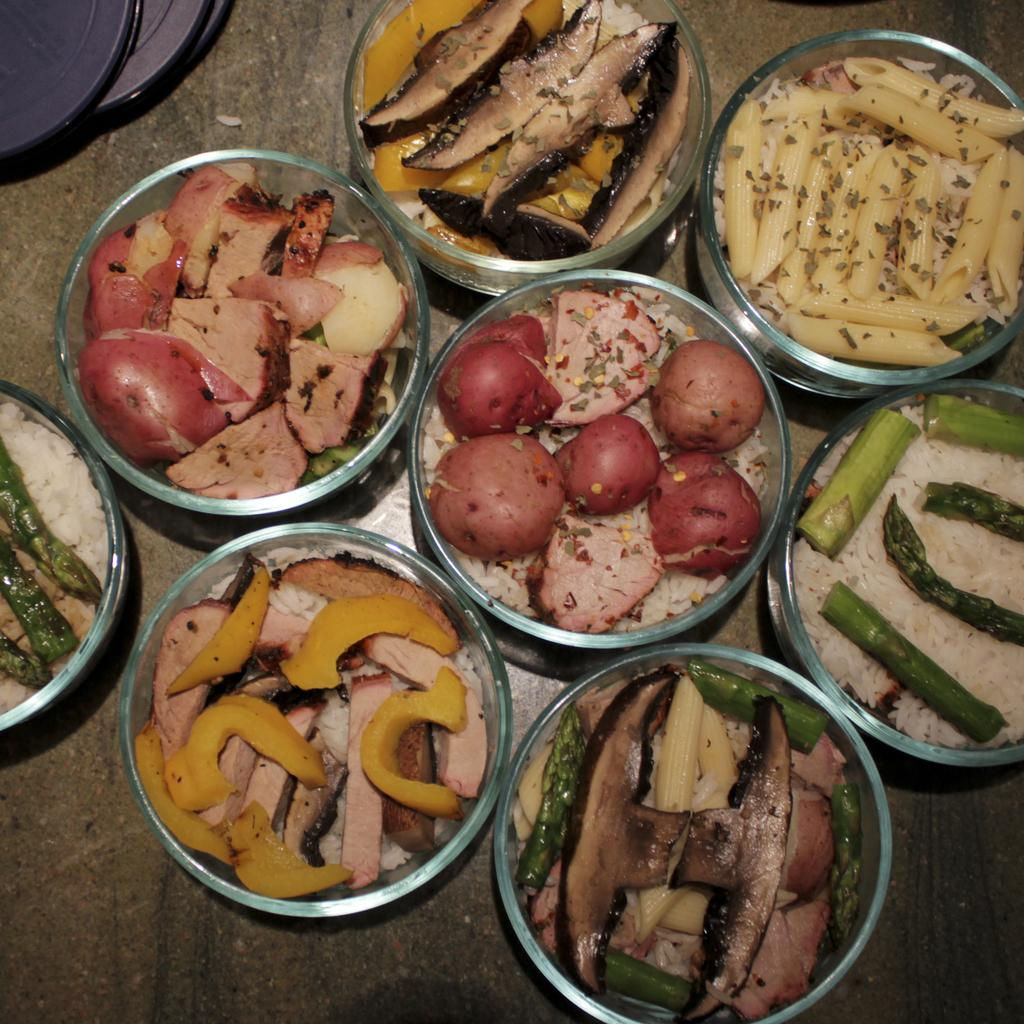How many bowls are visible in the image? There are multiple bowls in the image. What types of food can be seen in the bowls? There are eatables in the bowls, including meat, pasta, rice, and potatoes. Can you describe the different types of food in the image? Yes, there is meat, pasta, rice, and potatoes in the image. How many horses can be seen on the roof in the image? There are no horses or roof present in the image. What type of face can be seen on the potatoes in the image? There are no faces on the potatoes or any other items in the image. 